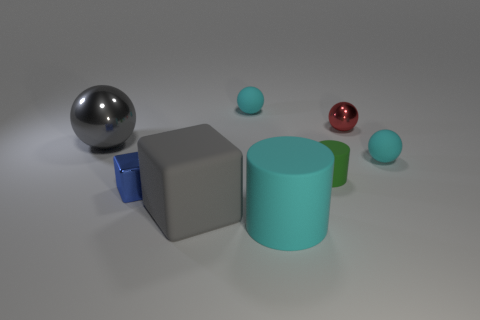Add 1 gray metallic balls. How many objects exist? 9 Subtract all small balls. How many balls are left? 1 Subtract 4 spheres. How many spheres are left? 0 Subtract all gray cubes. How many cubes are left? 1 Subtract all blocks. How many objects are left? 6 Subtract all purple blocks. Subtract all yellow spheres. How many blocks are left? 2 Subtract all green cylinders. How many blue blocks are left? 1 Subtract all tiny purple metallic cylinders. Subtract all gray metal spheres. How many objects are left? 7 Add 3 small spheres. How many small spheres are left? 6 Add 2 small yellow rubber objects. How many small yellow rubber objects exist? 2 